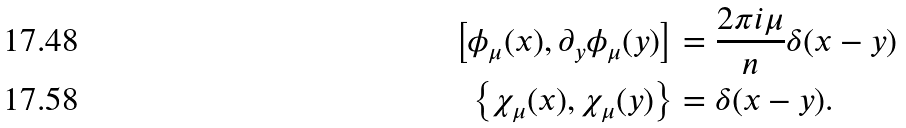Convert formula to latex. <formula><loc_0><loc_0><loc_500><loc_500>\left [ \phi _ { \mu } ( x ) , \partial _ { y } \phi _ { \mu } ( y ) \right ] & = \frac { 2 \pi i \mu } { n } \delta ( x - y ) \\ \left \{ \chi _ { \mu } ( x ) , \chi _ { \mu } ( y ) \right \} & = \delta ( x - y ) .</formula> 